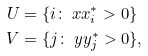Convert formula to latex. <formula><loc_0><loc_0><loc_500><loc_500>U & = \{ i \colon \ x x _ { i } ^ { * } > 0 \} \\ V & = \{ j \colon \ y y _ { j } ^ { * } > 0 \} ,</formula> 